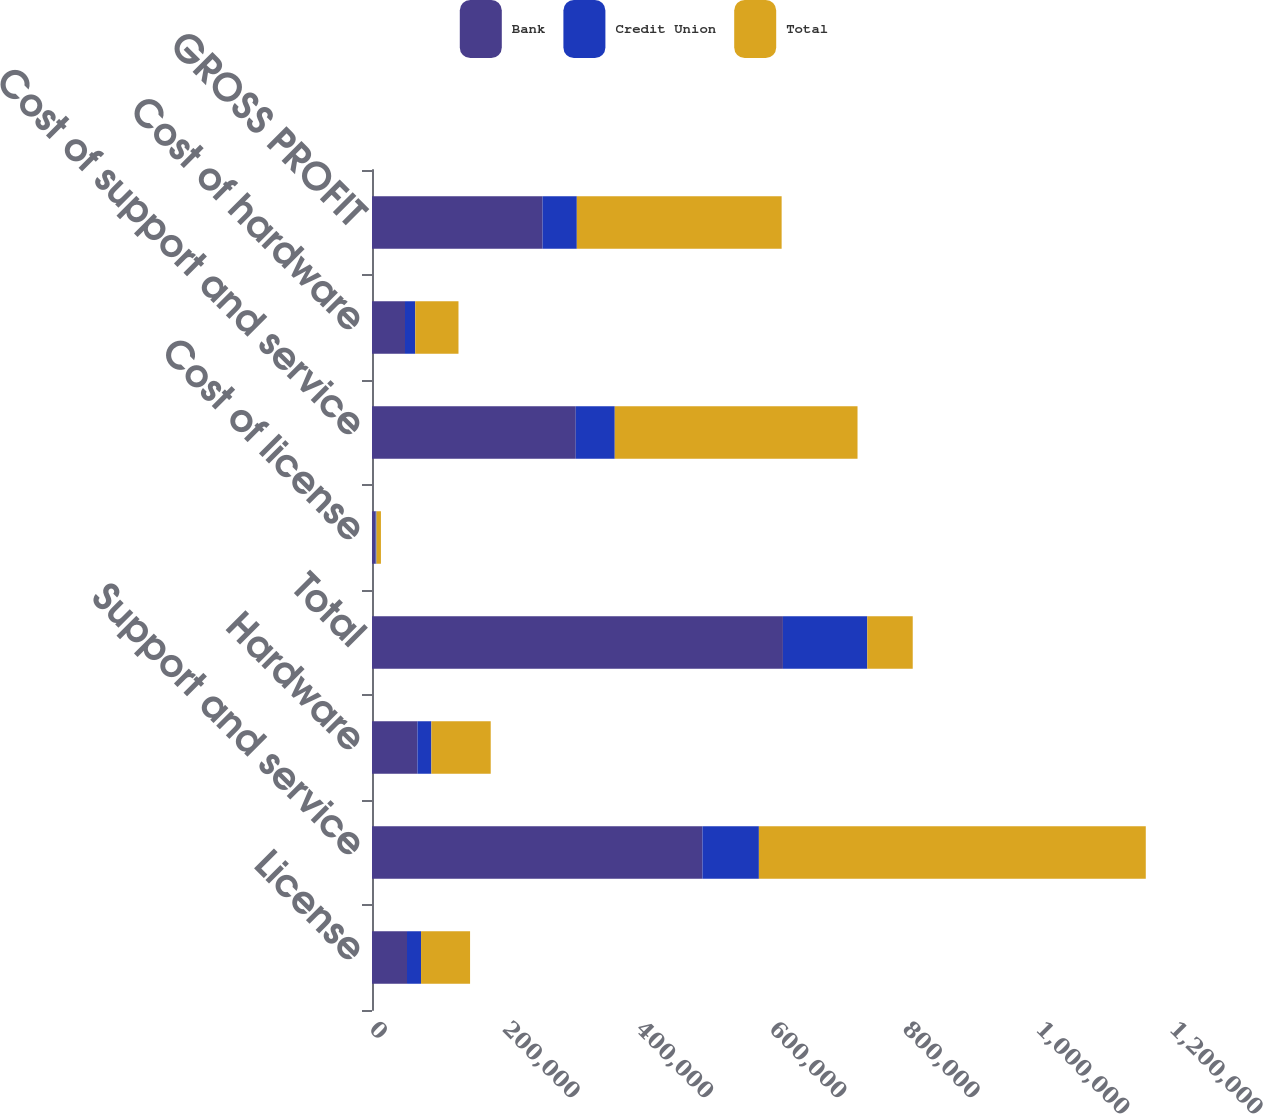Convert chart to OTSL. <chart><loc_0><loc_0><loc_500><loc_500><stacked_bar_chart><ecel><fcel>License<fcel>Support and service<fcel>Hardware<fcel>Total<fcel>Cost of license<fcel>Cost of support and service<fcel>Cost of hardware<fcel>GROSS PROFIT<nl><fcel>Bank<fcel>52528<fcel>495687<fcel>68175<fcel>616390<fcel>5376<fcel>305640<fcel>49504<fcel>255870<nl><fcel>Credit Union<fcel>21025<fcel>84647<fcel>20864<fcel>126536<fcel>1322<fcel>58500<fcel>15358<fcel>51356<nl><fcel>Total<fcel>73553<fcel>580334<fcel>89039<fcel>68175<fcel>6698<fcel>364140<fcel>64862<fcel>307226<nl></chart> 